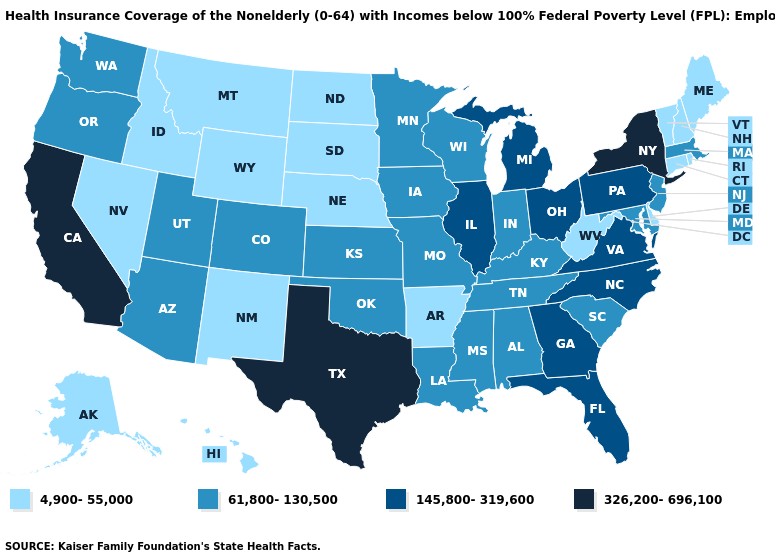Does the first symbol in the legend represent the smallest category?
Be succinct. Yes. What is the value of New Jersey?
Answer briefly. 61,800-130,500. Name the states that have a value in the range 145,800-319,600?
Be succinct. Florida, Georgia, Illinois, Michigan, North Carolina, Ohio, Pennsylvania, Virginia. Name the states that have a value in the range 4,900-55,000?
Answer briefly. Alaska, Arkansas, Connecticut, Delaware, Hawaii, Idaho, Maine, Montana, Nebraska, Nevada, New Hampshire, New Mexico, North Dakota, Rhode Island, South Dakota, Vermont, West Virginia, Wyoming. Name the states that have a value in the range 61,800-130,500?
Quick response, please. Alabama, Arizona, Colorado, Indiana, Iowa, Kansas, Kentucky, Louisiana, Maryland, Massachusetts, Minnesota, Mississippi, Missouri, New Jersey, Oklahoma, Oregon, South Carolina, Tennessee, Utah, Washington, Wisconsin. What is the value of Nevada?
Write a very short answer. 4,900-55,000. Name the states that have a value in the range 4,900-55,000?
Be succinct. Alaska, Arkansas, Connecticut, Delaware, Hawaii, Idaho, Maine, Montana, Nebraska, Nevada, New Hampshire, New Mexico, North Dakota, Rhode Island, South Dakota, Vermont, West Virginia, Wyoming. Among the states that border Alabama , which have the lowest value?
Answer briefly. Mississippi, Tennessee. What is the highest value in the USA?
Concise answer only. 326,200-696,100. What is the value of North Carolina?
Give a very brief answer. 145,800-319,600. Which states have the highest value in the USA?
Short answer required. California, New York, Texas. What is the highest value in the MidWest ?
Concise answer only. 145,800-319,600. What is the value of Alabama?
Write a very short answer. 61,800-130,500. What is the value of North Dakota?
Answer briefly. 4,900-55,000. What is the lowest value in the Northeast?
Be succinct. 4,900-55,000. 